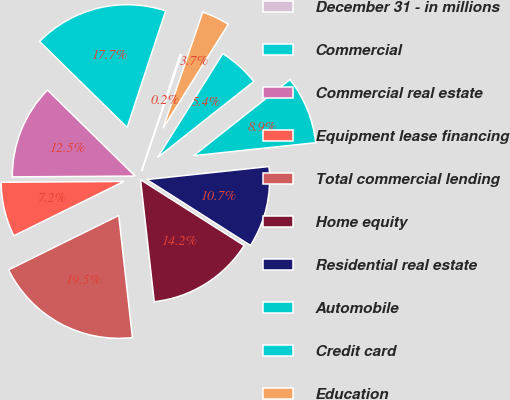<chart> <loc_0><loc_0><loc_500><loc_500><pie_chart><fcel>December 31 - in millions<fcel>Commercial<fcel>Commercial real estate<fcel>Equipment lease financing<fcel>Total commercial lending<fcel>Home equity<fcel>Residential real estate<fcel>Automobile<fcel>Credit card<fcel>Education<nl><fcel>0.17%<fcel>17.72%<fcel>12.46%<fcel>7.19%<fcel>19.48%<fcel>14.21%<fcel>10.7%<fcel>8.95%<fcel>5.44%<fcel>3.68%<nl></chart> 